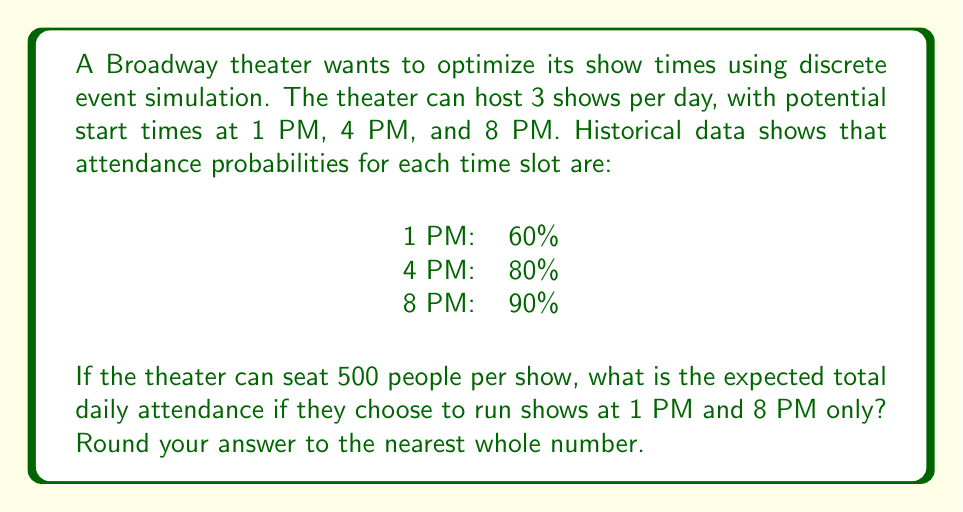Give your solution to this math problem. Let's approach this step-by-step:

1) First, we need to calculate the expected attendance for each show time:

   1 PM show: $500 \times 0.60 = 300$ people
   8 PM show: $500 \times 0.90 = 450$ people

2) The theater is running two shows, so we need to sum these expectations:

   $E(\text{Total Attendance}) = E(\text{1 PM}) + E(\text{8 PM})$

3) Substituting the values:

   $E(\text{Total Attendance}) = 300 + 450 = 750$ people

4) The question asks for the nearest whole number, but 750 is already a whole number, so no rounding is necessary.

This discrete event simulation model assumes independence between show times and uses expected values based on historical probabilities. In a more complex model, we might consider factors like day of the week, season, or competing events.
Answer: 750 people 